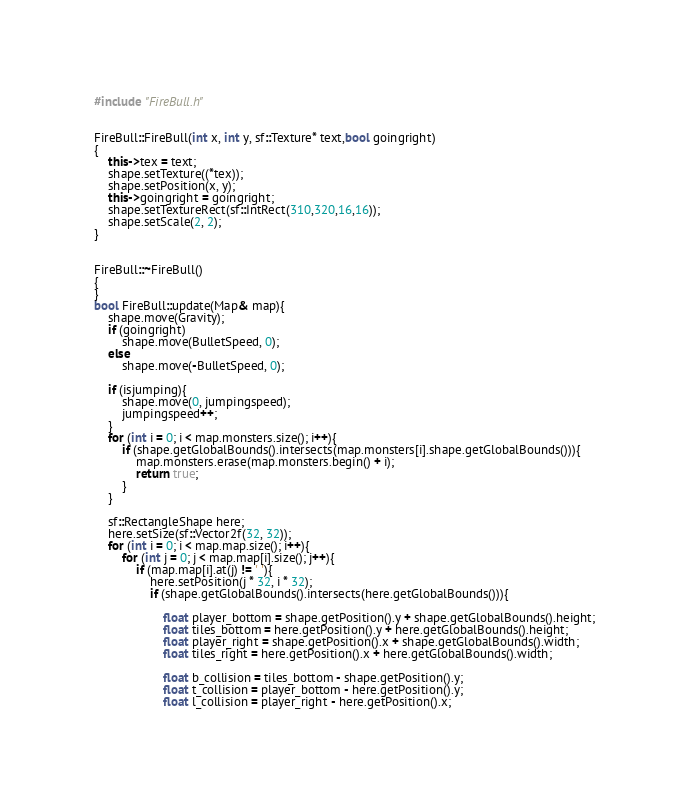<code> <loc_0><loc_0><loc_500><loc_500><_C++_>#include "FireBull.h"


FireBull::FireBull(int x, int y, sf::Texture* text,bool goingright)
{
	this->tex = text;
	shape.setTexture((*tex));
	shape.setPosition(x, y);
	this->goingright = goingright;
	shape.setTextureRect(sf::IntRect(310,320,16,16));
	shape.setScale(2, 2);
}


FireBull::~FireBull()
{
}
bool FireBull::update(Map& map){
	shape.move(Gravity);
	if (goingright)
		shape.move(BulletSpeed, 0);
	else
		shape.move(-BulletSpeed, 0);

	if (isjumping){
		shape.move(0, jumpingspeed);
		jumpingspeed++;
	}
	for (int i = 0; i < map.monsters.size(); i++){
		if (shape.getGlobalBounds().intersects(map.monsters[i].shape.getGlobalBounds())){
			map.monsters.erase(map.monsters.begin() + i);
			return true;
		}
	}

	sf::RectangleShape here;
	here.setSize(sf::Vector2f(32, 32));
	for (int i = 0; i < map.map.size(); i++){
		for (int j = 0; j < map.map[i].size(); j++){
			if (map.map[i].at(j) != ' '){
				here.setPosition(j * 32, i * 32);
				if (shape.getGlobalBounds().intersects(here.getGlobalBounds())){

					float player_bottom = shape.getPosition().y + shape.getGlobalBounds().height;
					float tiles_bottom = here.getPosition().y + here.getGlobalBounds().height;
					float player_right = shape.getPosition().x + shape.getGlobalBounds().width;
					float tiles_right = here.getPosition().x + here.getGlobalBounds().width;

					float b_collision = tiles_bottom - shape.getPosition().y;
					float t_collision = player_bottom - here.getPosition().y;
					float l_collision = player_right - here.getPosition().x;</code> 